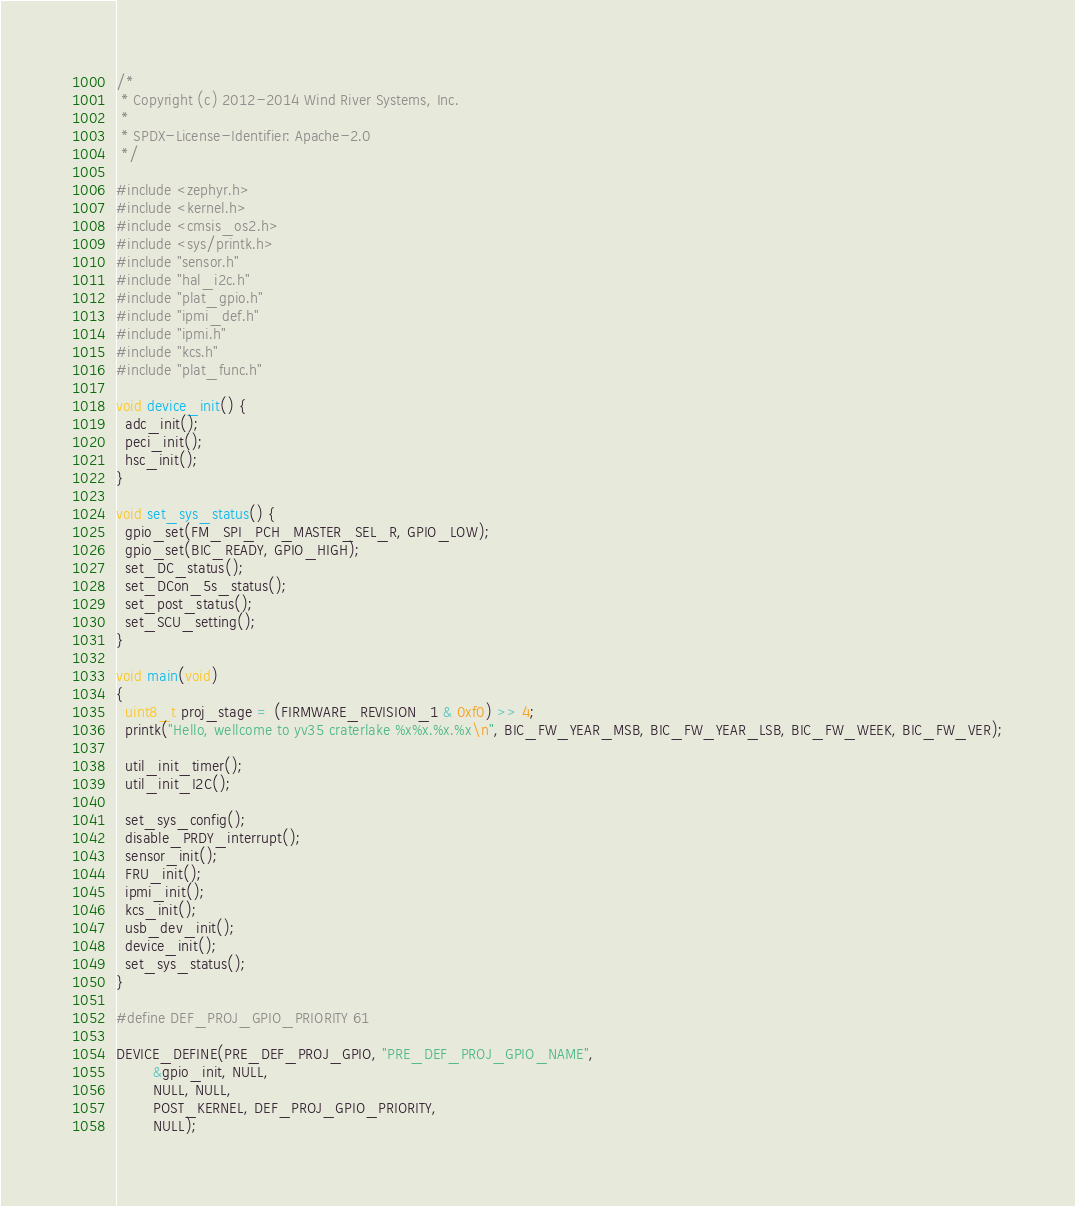<code> <loc_0><loc_0><loc_500><loc_500><_C_>/*
 * Copyright (c) 2012-2014 Wind River Systems, Inc.
 *
 * SPDX-License-Identifier: Apache-2.0
 */

#include <zephyr.h>
#include <kernel.h>
#include <cmsis_os2.h>
#include <sys/printk.h>
#include "sensor.h"
#include "hal_i2c.h"
#include "plat_gpio.h"
#include "ipmi_def.h"
#include "ipmi.h"
#include "kcs.h"
#include "plat_func.h"

void device_init() {
  adc_init();
  peci_init();
  hsc_init();
}

void set_sys_status() {
  gpio_set(FM_SPI_PCH_MASTER_SEL_R, GPIO_LOW);
  gpio_set(BIC_READY, GPIO_HIGH);
  set_DC_status();
  set_DCon_5s_status();
  set_post_status();
  set_SCU_setting();
}

void main(void)
{
  uint8_t proj_stage = (FIRMWARE_REVISION_1 & 0xf0) >> 4;
  printk("Hello, wellcome to yv35 craterlake %x%x.%x.%x\n", BIC_FW_YEAR_MSB, BIC_FW_YEAR_LSB, BIC_FW_WEEK, BIC_FW_VER);

  util_init_timer();
  util_init_I2C();

  set_sys_config();
  disable_PRDY_interrupt();
  sensor_init();
  FRU_init();
  ipmi_init();
  kcs_init();
  usb_dev_init();
  device_init();
  set_sys_status();
}

#define DEF_PROJ_GPIO_PRIORITY 61

DEVICE_DEFINE(PRE_DEF_PROJ_GPIO, "PRE_DEF_PROJ_GPIO_NAME",
        &gpio_init, NULL,
        NULL, NULL,
        POST_KERNEL, DEF_PROJ_GPIO_PRIORITY,
        NULL);
</code> 